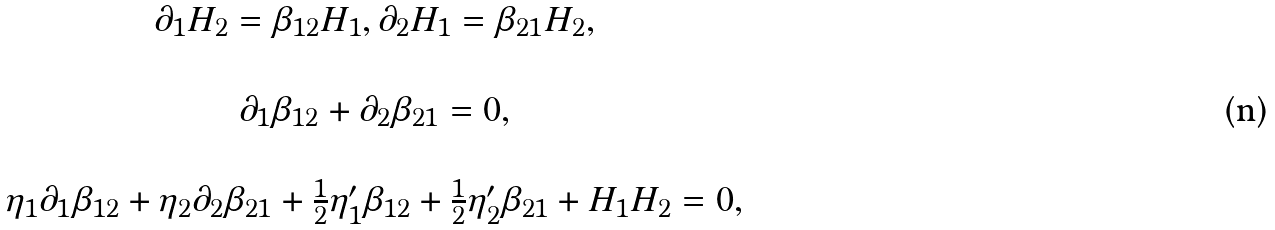<formula> <loc_0><loc_0><loc_500><loc_500>\begin{array} { c } \partial _ { 1 } H _ { 2 } = \beta _ { 1 2 } H _ { 1 } , \partial _ { 2 } H _ { 1 } = \beta _ { 2 1 } H _ { 2 } , \\ \ \\ \partial _ { 1 } \beta _ { 1 2 } + \partial _ { 2 } \beta _ { 2 1 } = 0 , \\ \ \\ \eta _ { 1 } \partial _ { 1 } \beta _ { 1 2 } + \eta _ { 2 } \partial _ { 2 } \beta _ { 2 1 } + \frac { 1 } { 2 } \eta _ { 1 } ^ { \prime } \beta _ { 1 2 } + \frac { 1 } { 2 } \eta _ { 2 } ^ { \prime } \beta _ { 2 1 } + H _ { 1 } H _ { 2 } = 0 , \end{array}</formula> 